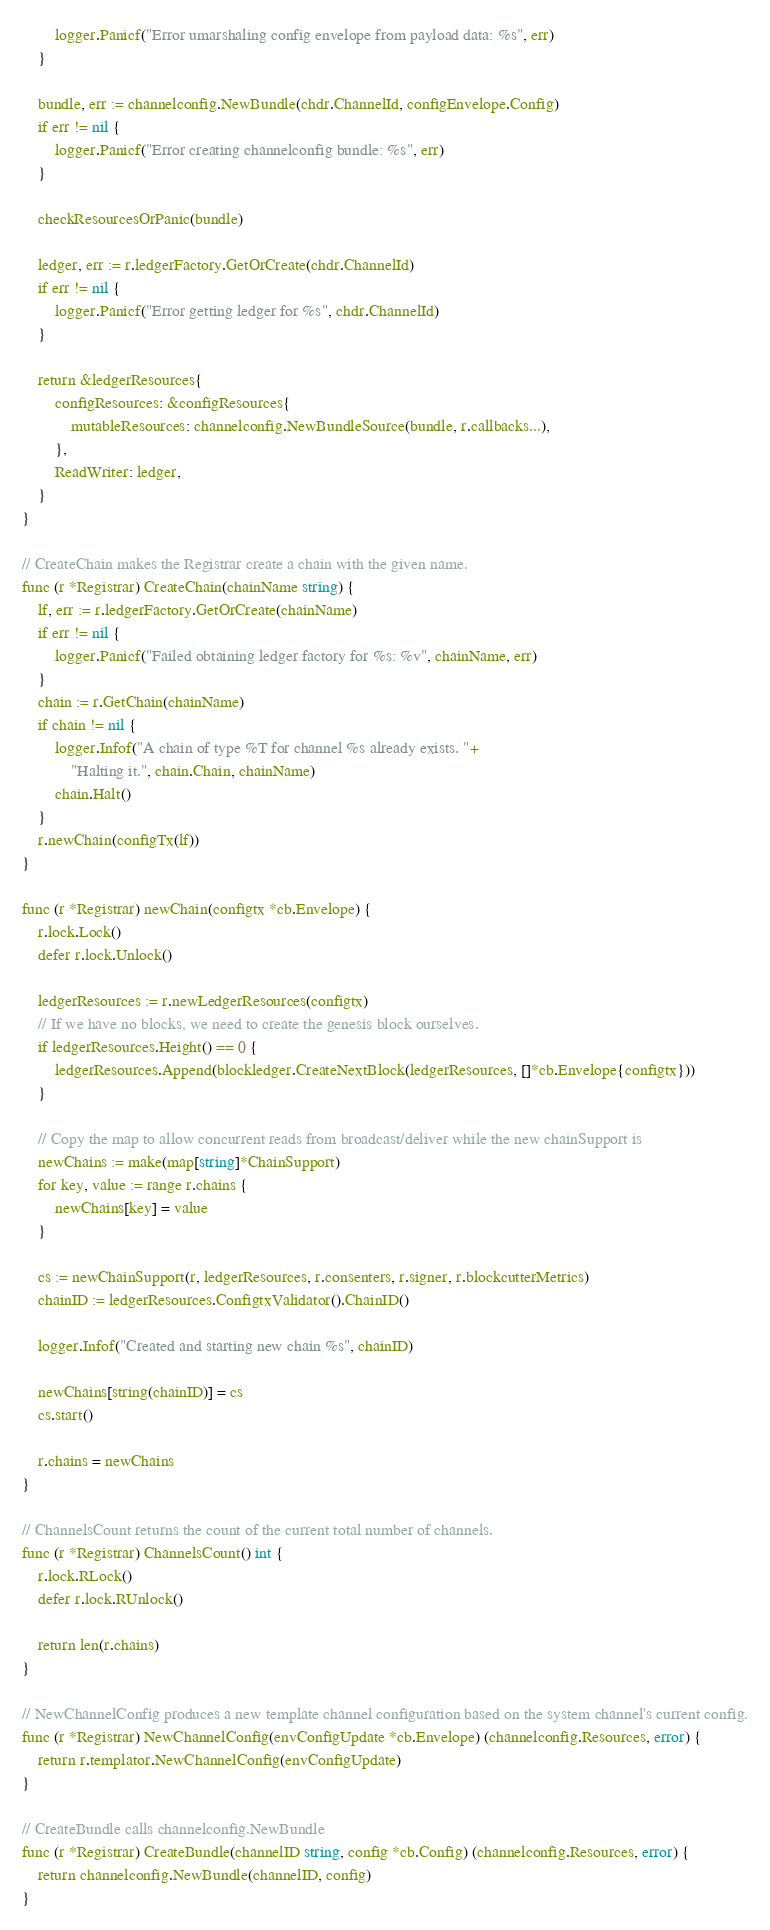Convert code to text. <code><loc_0><loc_0><loc_500><loc_500><_Go_>		logger.Panicf("Error umarshaling config envelope from payload data: %s", err)
	}

	bundle, err := channelconfig.NewBundle(chdr.ChannelId, configEnvelope.Config)
	if err != nil {
		logger.Panicf("Error creating channelconfig bundle: %s", err)
	}

	checkResourcesOrPanic(bundle)

	ledger, err := r.ledgerFactory.GetOrCreate(chdr.ChannelId)
	if err != nil {
		logger.Panicf("Error getting ledger for %s", chdr.ChannelId)
	}

	return &ledgerResources{
		configResources: &configResources{
			mutableResources: channelconfig.NewBundleSource(bundle, r.callbacks...),
		},
		ReadWriter: ledger,
	}
}

// CreateChain makes the Registrar create a chain with the given name.
func (r *Registrar) CreateChain(chainName string) {
	lf, err := r.ledgerFactory.GetOrCreate(chainName)
	if err != nil {
		logger.Panicf("Failed obtaining ledger factory for %s: %v", chainName, err)
	}
	chain := r.GetChain(chainName)
	if chain != nil {
		logger.Infof("A chain of type %T for channel %s already exists. "+
			"Halting it.", chain.Chain, chainName)
		chain.Halt()
	}
	r.newChain(configTx(lf))
}

func (r *Registrar) newChain(configtx *cb.Envelope) {
	r.lock.Lock()
	defer r.lock.Unlock()

	ledgerResources := r.newLedgerResources(configtx)
	// If we have no blocks, we need to create the genesis block ourselves.
	if ledgerResources.Height() == 0 {
		ledgerResources.Append(blockledger.CreateNextBlock(ledgerResources, []*cb.Envelope{configtx}))
	}

	// Copy the map to allow concurrent reads from broadcast/deliver while the new chainSupport is
	newChains := make(map[string]*ChainSupport)
	for key, value := range r.chains {
		newChains[key] = value
	}

	cs := newChainSupport(r, ledgerResources, r.consenters, r.signer, r.blockcutterMetrics)
	chainID := ledgerResources.ConfigtxValidator().ChainID()

	logger.Infof("Created and starting new chain %s", chainID)

	newChains[string(chainID)] = cs
	cs.start()

	r.chains = newChains
}

// ChannelsCount returns the count of the current total number of channels.
func (r *Registrar) ChannelsCount() int {
	r.lock.RLock()
	defer r.lock.RUnlock()

	return len(r.chains)
}

// NewChannelConfig produces a new template channel configuration based on the system channel's current config.
func (r *Registrar) NewChannelConfig(envConfigUpdate *cb.Envelope) (channelconfig.Resources, error) {
	return r.templator.NewChannelConfig(envConfigUpdate)
}

// CreateBundle calls channelconfig.NewBundle
func (r *Registrar) CreateBundle(channelID string, config *cb.Config) (channelconfig.Resources, error) {
	return channelconfig.NewBundle(channelID, config)
}
</code> 